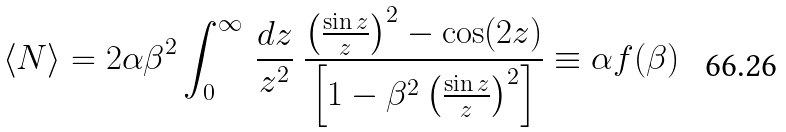Convert formula to latex. <formula><loc_0><loc_0><loc_500><loc_500>\left \langle N \right \rangle = 2 \alpha \beta ^ { 2 } \int ^ { \infty } _ { 0 } \, \frac { d z } { z ^ { 2 } } \ \frac { \left ( \frac { \sin z } { z } \right ) ^ { 2 } - \cos ( 2 z ) } { \left [ 1 - \beta ^ { 2 } \left ( \frac { \sin z } { z } \right ) ^ { 2 } \right ] } \equiv \alpha f ( \beta )</formula> 